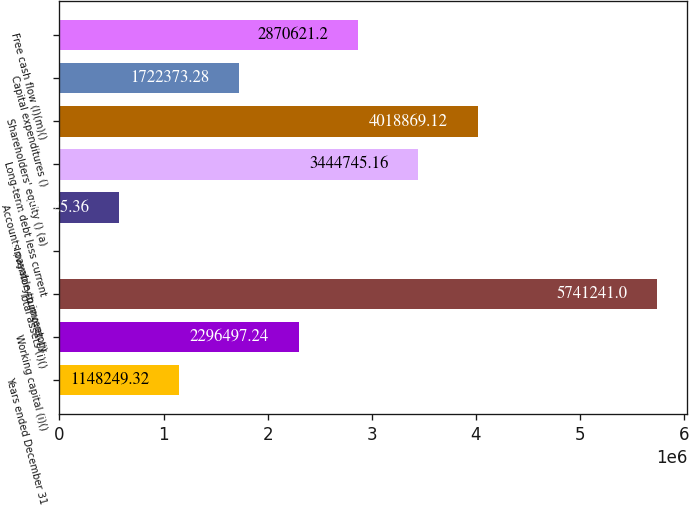Convert chart to OTSL. <chart><loc_0><loc_0><loc_500><loc_500><bar_chart><fcel>Years ended December 31<fcel>Working capital (i)()<fcel>Total assets (i)()<fcel>Inventory turnover (j)<fcel>Accounts payable to inventory<fcel>Long-term debt less current<fcel>Shareholders' equity () (a)<fcel>Capital expenditures ()<fcel>Free cash flow (l)(m)()<nl><fcel>1.14825e+06<fcel>2.2965e+06<fcel>5.74124e+06<fcel>1.4<fcel>574125<fcel>3.44475e+06<fcel>4.01887e+06<fcel>1.72237e+06<fcel>2.87062e+06<nl></chart> 